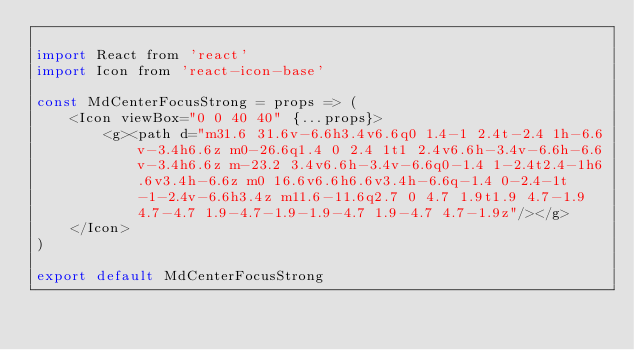<code> <loc_0><loc_0><loc_500><loc_500><_JavaScript_>
import React from 'react'
import Icon from 'react-icon-base'

const MdCenterFocusStrong = props => (
    <Icon viewBox="0 0 40 40" {...props}>
        <g><path d="m31.6 31.6v-6.6h3.4v6.6q0 1.4-1 2.4t-2.4 1h-6.6v-3.4h6.6z m0-26.6q1.4 0 2.4 1t1 2.4v6.6h-3.4v-6.6h-6.6v-3.4h6.6z m-23.2 3.4v6.6h-3.4v-6.6q0-1.4 1-2.4t2.4-1h6.6v3.4h-6.6z m0 16.6v6.6h6.6v3.4h-6.6q-1.4 0-2.4-1t-1-2.4v-6.6h3.4z m11.6-11.6q2.7 0 4.7 1.9t1.9 4.7-1.9 4.7-4.7 1.9-4.7-1.9-1.9-4.7 1.9-4.7 4.7-1.9z"/></g>
    </Icon>
)

export default MdCenterFocusStrong
</code> 